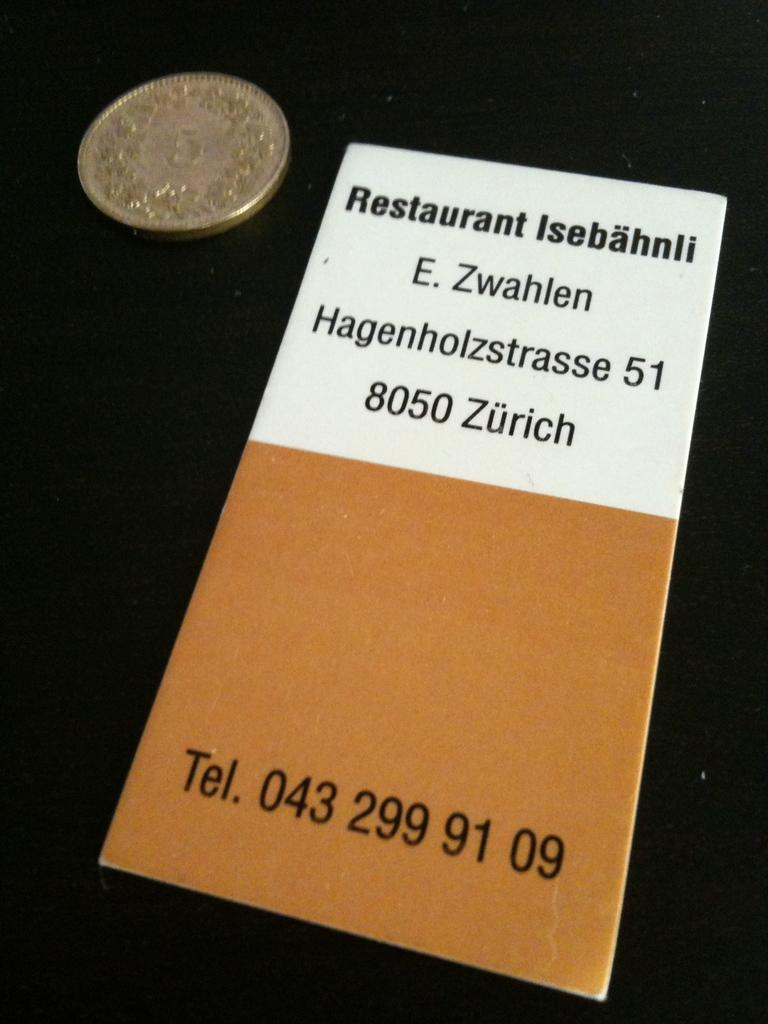Provide a one-sentence caption for the provided image. A pamphlet titled Restaurant Isebahnli and the address E. Zwahlen Hagenholzstrasse 51 8050 Zurich and the telephone number 043 299 91 09. 